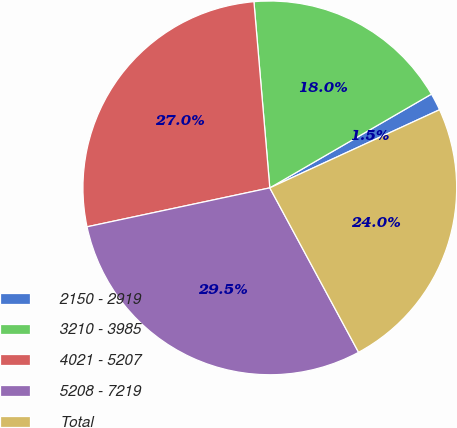Convert chart. <chart><loc_0><loc_0><loc_500><loc_500><pie_chart><fcel>2150 - 2919<fcel>3210 - 3985<fcel>4021 - 5207<fcel>5208 - 7219<fcel>Total<nl><fcel>1.5%<fcel>17.99%<fcel>26.99%<fcel>29.54%<fcel>23.99%<nl></chart> 